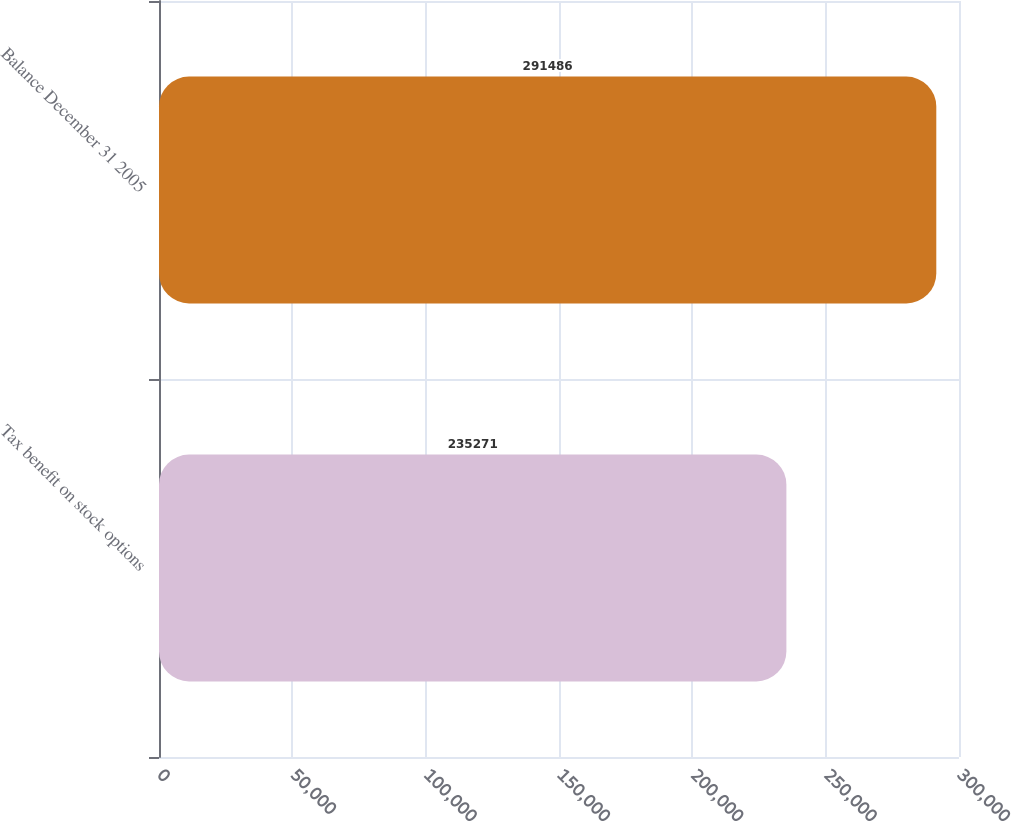<chart> <loc_0><loc_0><loc_500><loc_500><bar_chart><fcel>Tax benefit on stock options<fcel>Balance December 31 2005<nl><fcel>235271<fcel>291486<nl></chart> 